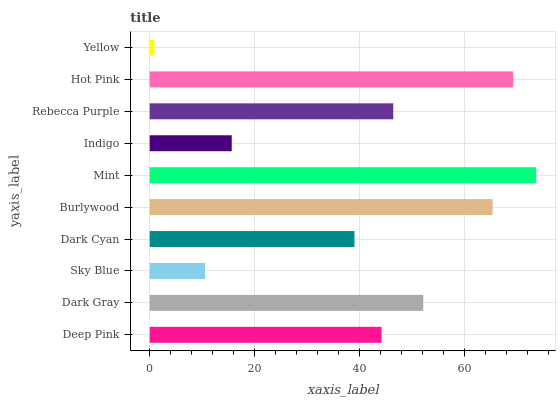Is Yellow the minimum?
Answer yes or no. Yes. Is Mint the maximum?
Answer yes or no. Yes. Is Dark Gray the minimum?
Answer yes or no. No. Is Dark Gray the maximum?
Answer yes or no. No. Is Dark Gray greater than Deep Pink?
Answer yes or no. Yes. Is Deep Pink less than Dark Gray?
Answer yes or no. Yes. Is Deep Pink greater than Dark Gray?
Answer yes or no. No. Is Dark Gray less than Deep Pink?
Answer yes or no. No. Is Rebecca Purple the high median?
Answer yes or no. Yes. Is Deep Pink the low median?
Answer yes or no. Yes. Is Hot Pink the high median?
Answer yes or no. No. Is Yellow the low median?
Answer yes or no. No. 